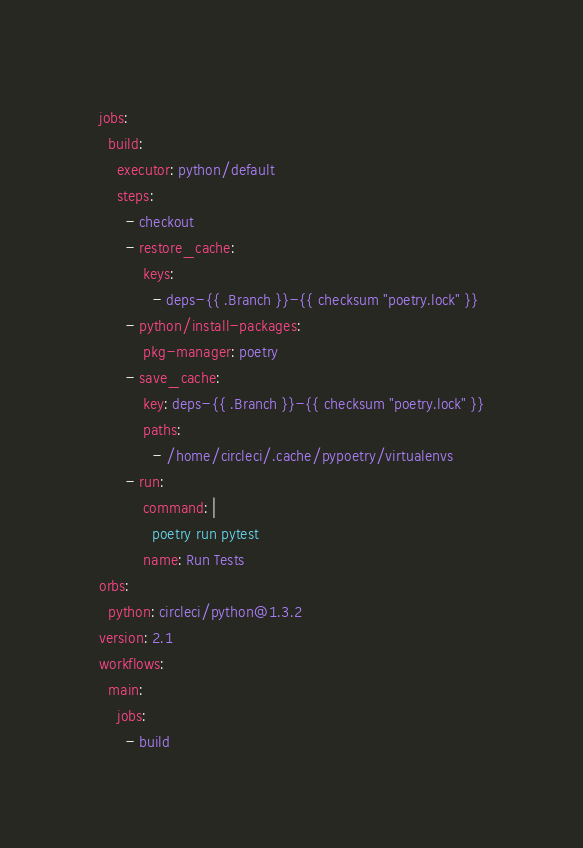Convert code to text. <code><loc_0><loc_0><loc_500><loc_500><_YAML_>jobs:
  build:
    executor: python/default
    steps:
      - checkout
      - restore_cache:
          keys:
            - deps-{{ .Branch }}-{{ checksum "poetry.lock" }}
      - python/install-packages:
          pkg-manager: poetry
      - save_cache:
          key: deps-{{ .Branch }}-{{ checksum "poetry.lock" }}
          paths:
            - /home/circleci/.cache/pypoetry/virtualenvs
      - run:
          command: |
            poetry run pytest
          name: Run Tests
orbs:
  python: circleci/python@1.3.2
version: 2.1
workflows:
  main:
    jobs:
      - build
</code> 